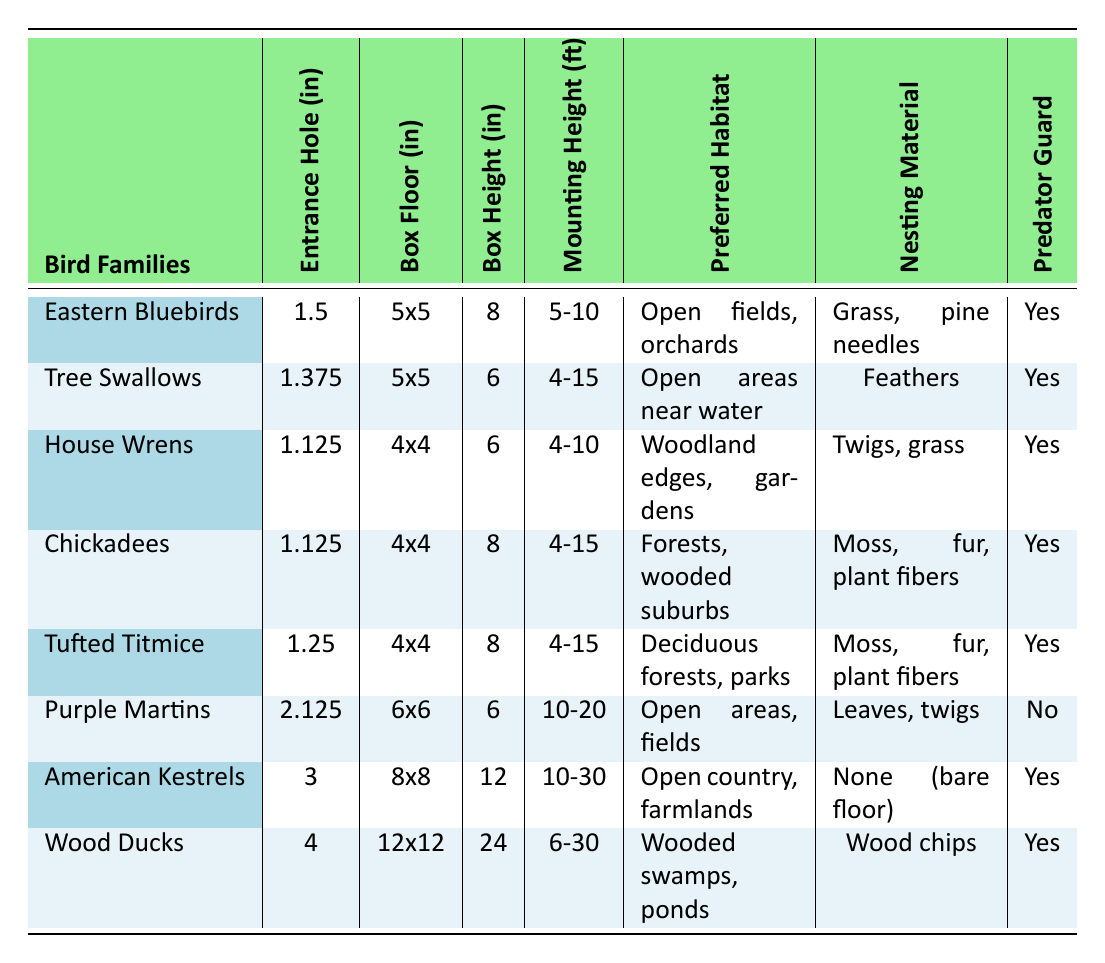What is the entrance hole diameter for Wood Ducks? From the table, under the "Entrance Hole (in)" column for "Wood Ducks," the value is 4 inches.
Answer: 4 How many bird families require a predator guard? By counting the rows where "Predator Guard" is marked as Yes, we see that it is true for 6 out of the 8 families.
Answer: 6 What is the box height of American Kestrels? Looking under the "Box Height (in)" column for "American Kestrels," the box height is 12 inches.
Answer: 12 Which bird family has the largest box floor size? The largest box floor size is 12x12 inches, which corresponds to "Wood Ducks."
Answer: Wood Ducks What is the average entrance hole diameter for all bird families? The entrance hole diameters are 1.5, 1.375, 1.125, 1.125, 1.25, 2.125, 3, and 4 inches. Adding them gives a total of 14.375 inches. There are 8 families, so the average is 14.375/8 = 1.796.
Answer: 1.796 Does the box height for Chickadees exceed 8 inches? The table shows that the box height for "Chickadees" is 8 inches, which does not exceed 8.
Answer: No What preferred habitat is shared by both Tufted Titmice and Chickadees? "Tufted Titmice" and "Chickadees" both prefer habitats in "Forests, wooded suburbs," as indicated in their respective rows in the table.
Answer: Forests, wooded suburbs Which bird families prefer open areas near water? From the table, only "Tree Swallows" are mentioned as preferring "Open areas near water."
Answer: Tree Swallows Which bird family has the smallest entrance hole diameter? The smallest entrance hole diameter is 1.125 inches, applicable to both "House Wrens" and "Chickadees."
Answer: House Wrens and Chickadees 